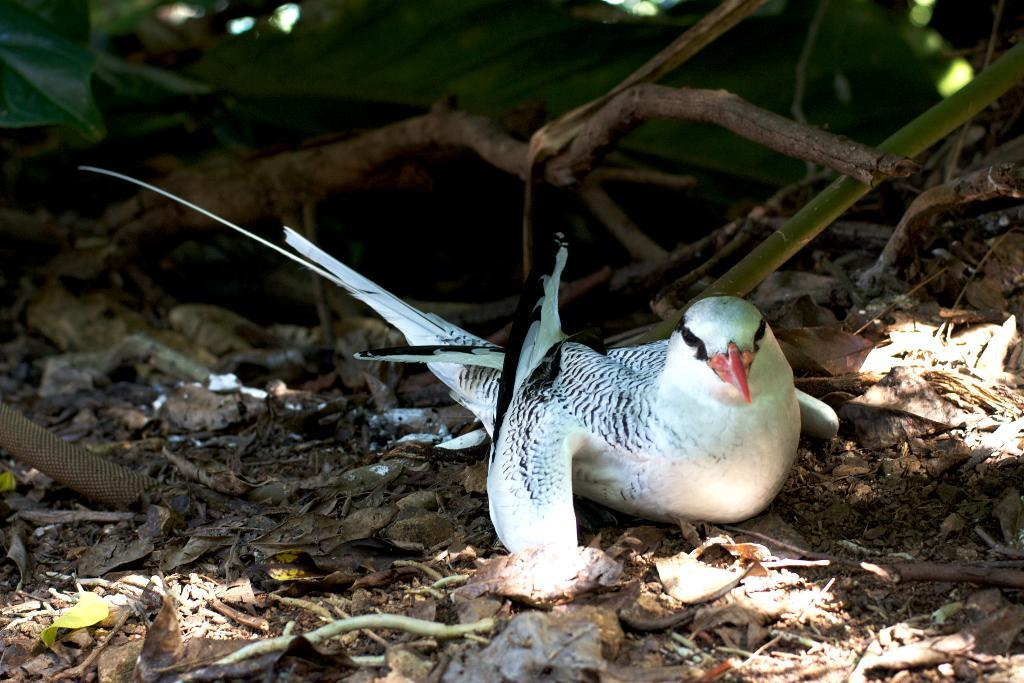What is the bird doing in the image? The bird is sitting on the ground in the image. What can be seen at the top of the image? There are dried sticks at the top of the image. What type of vegetation is visible in the background of the image? There are green leaves in the background of the image. What is visible on the right side of the image? There is a stem visible on the right side of the image. What degree of difficulty is the bird attempting in the image? The image does not depict the bird attempting any specific degree of difficulty; it is simply sitting on the ground. 